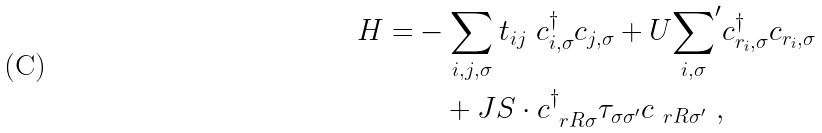Convert formula to latex. <formula><loc_0><loc_0><loc_500><loc_500>H = & - \sum _ { { i , j } , \sigma } t _ { i j } \ c ^ { \dagger } _ { { i } , \sigma } c _ { { j } , \sigma } + U { \sum _ { i , \sigma } } ^ { \prime } c ^ { \dagger } _ { { r } _ { i } , \sigma } c _ { { r } _ { i } , \sigma } \\ & \quad + J { S } \cdot c ^ { \dagger } _ { \ r R \sigma } { \tau } _ { \sigma \sigma ^ { \prime } } c _ { \ r R \sigma ^ { \prime } } \ ,</formula> 